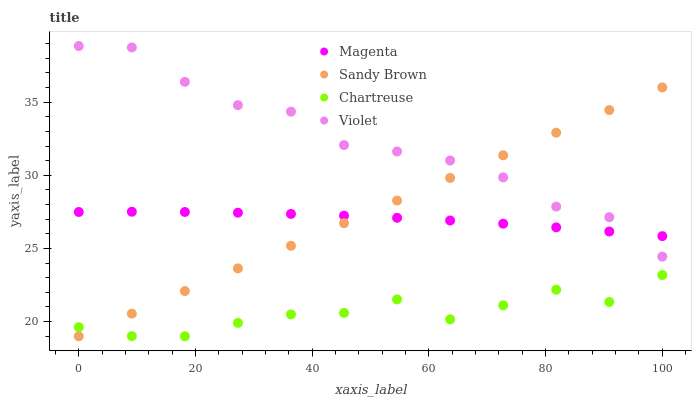Does Chartreuse have the minimum area under the curve?
Answer yes or no. Yes. Does Violet have the maximum area under the curve?
Answer yes or no. Yes. Does Sandy Brown have the minimum area under the curve?
Answer yes or no. No. Does Sandy Brown have the maximum area under the curve?
Answer yes or no. No. Is Sandy Brown the smoothest?
Answer yes or no. Yes. Is Violet the roughest?
Answer yes or no. Yes. Is Chartreuse the smoothest?
Answer yes or no. No. Is Chartreuse the roughest?
Answer yes or no. No. Does Sandy Brown have the lowest value?
Answer yes or no. Yes. Does Violet have the lowest value?
Answer yes or no. No. Does Violet have the highest value?
Answer yes or no. Yes. Does Sandy Brown have the highest value?
Answer yes or no. No. Is Chartreuse less than Violet?
Answer yes or no. Yes. Is Magenta greater than Chartreuse?
Answer yes or no. Yes. Does Violet intersect Magenta?
Answer yes or no. Yes. Is Violet less than Magenta?
Answer yes or no. No. Is Violet greater than Magenta?
Answer yes or no. No. Does Chartreuse intersect Violet?
Answer yes or no. No. 